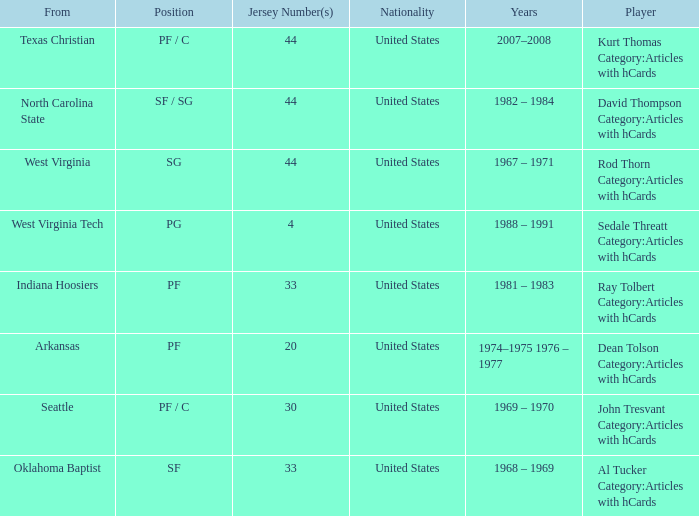What years did the player with the jersey number bigger than 20 play? 2007–2008, 1982 – 1984, 1967 – 1971, 1981 – 1983, 1969 – 1970, 1968 – 1969. 